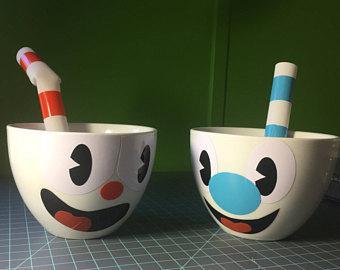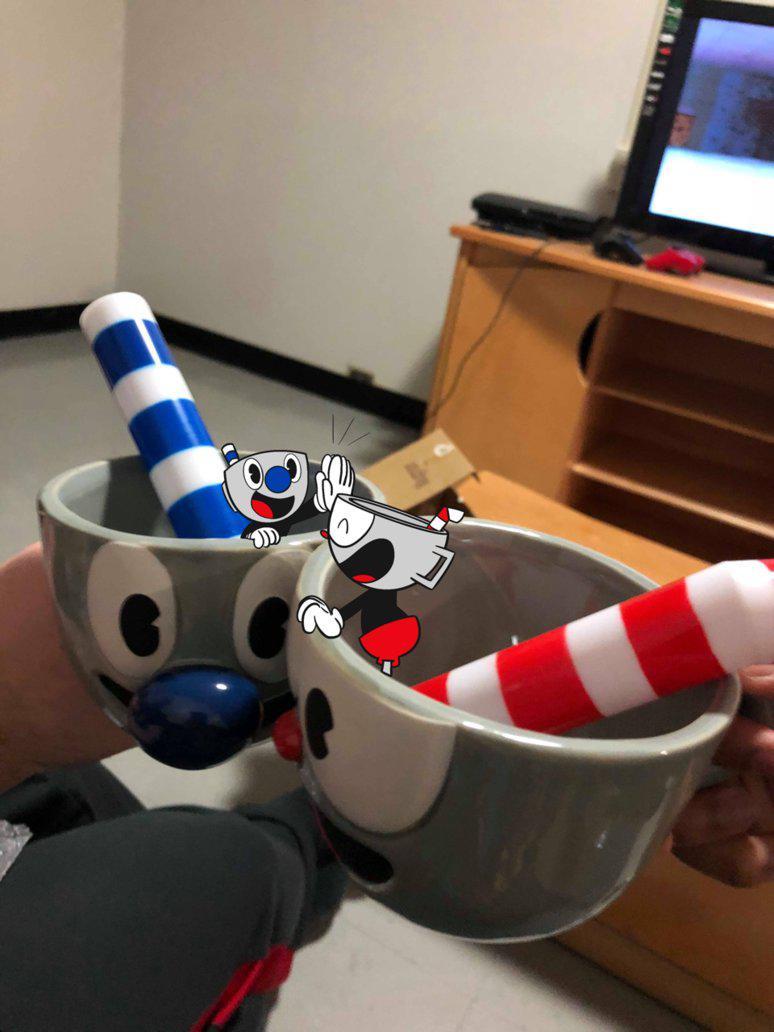The first image is the image on the left, the second image is the image on the right. Considering the images on both sides, is "An equal number of cups with a face design are in each image, a fat striped straw in each cup." valid? Answer yes or no. Yes. The first image is the image on the left, the second image is the image on the right. Evaluate the accuracy of this statement regarding the images: "The left and right image contains the same number porcelain of smiley face cups.". Is it true? Answer yes or no. Yes. 